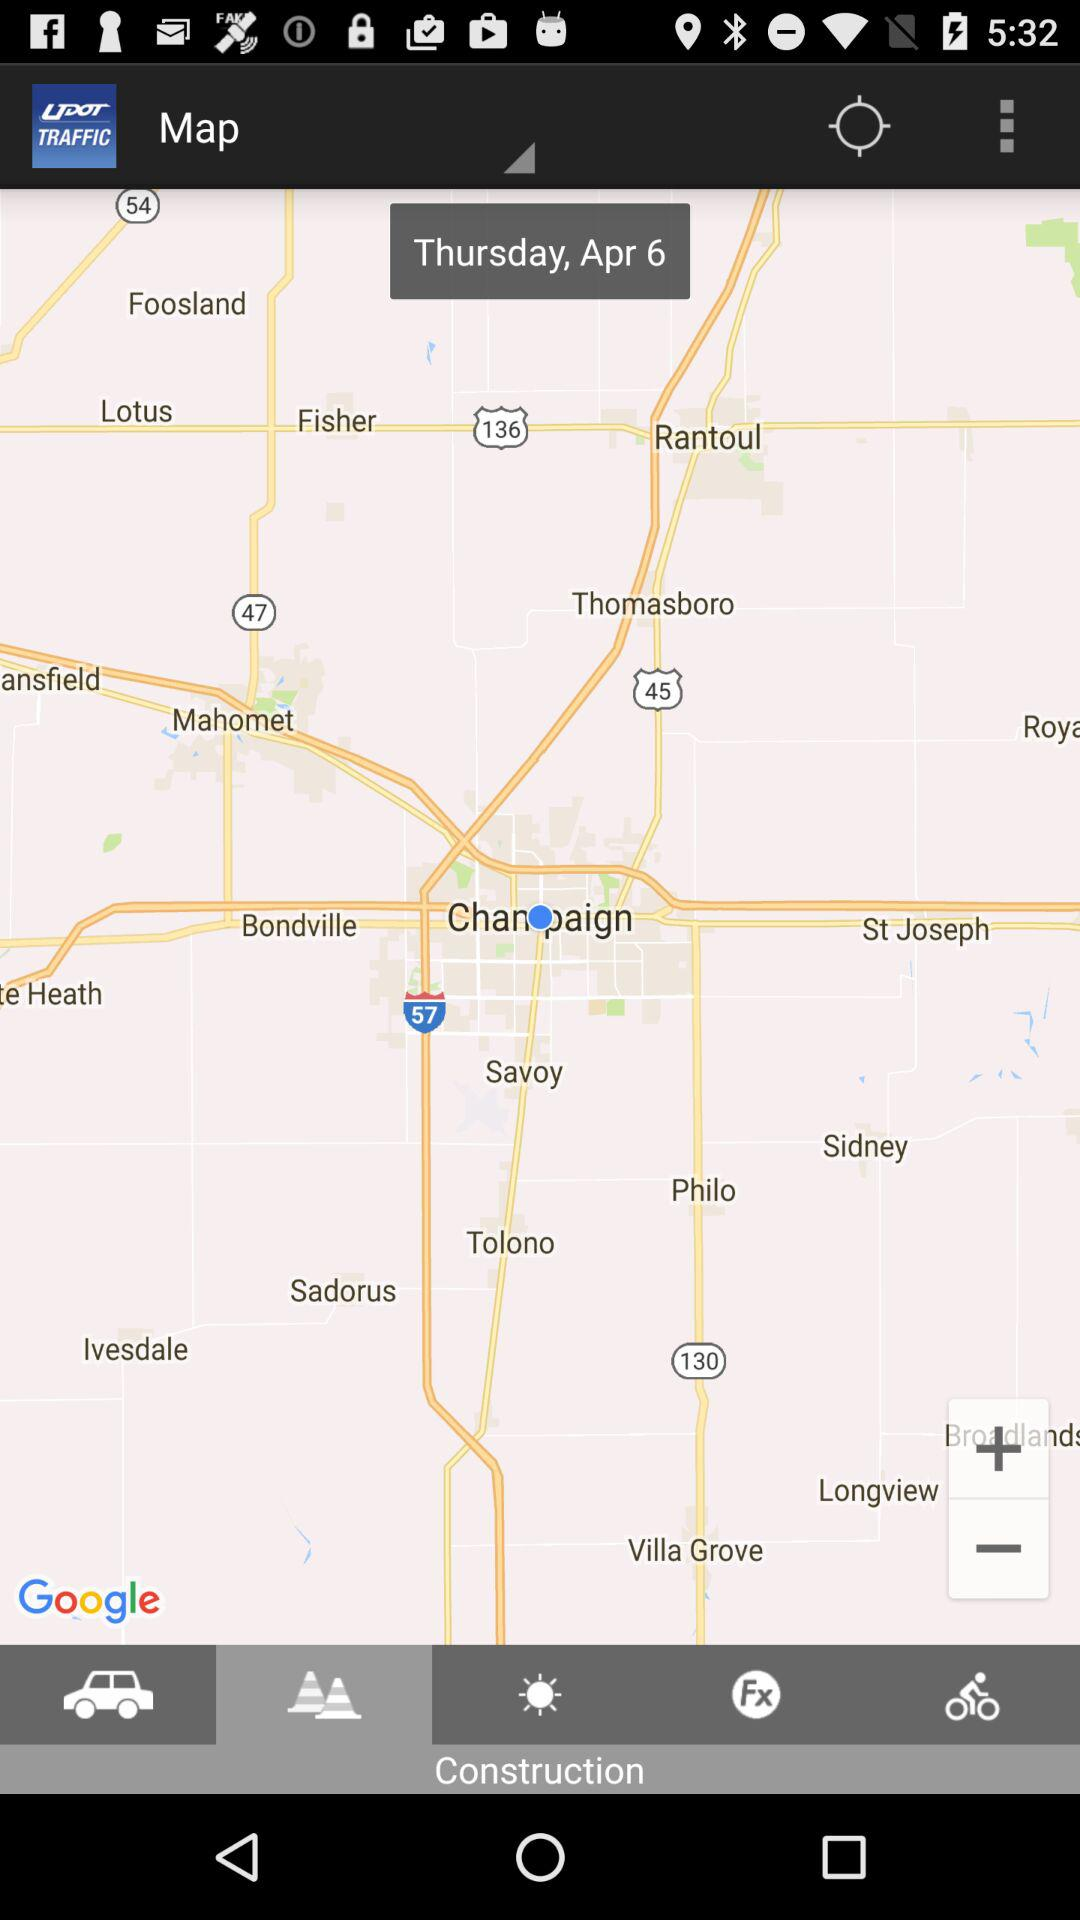What is the selected date? The selected date is Thursday, April 6. 